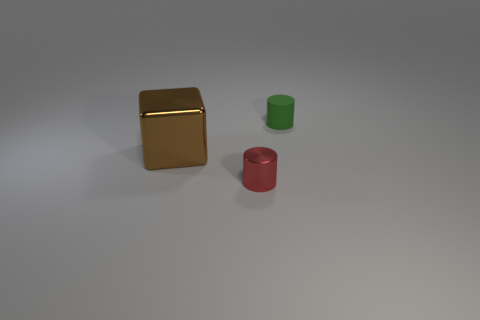Is the number of small red cylinders greater than the number of yellow objects?
Make the answer very short. Yes. Is there any other thing of the same color as the small shiny cylinder?
Keep it short and to the point. No. Do the tiny red cylinder and the small green cylinder have the same material?
Your response must be concise. No. Are there fewer small red metal objects than brown shiny cylinders?
Make the answer very short. No. Is the shape of the brown thing the same as the small green matte thing?
Provide a short and direct response. No. The tiny metal cylinder has what color?
Provide a short and direct response. Red. What number of other things are made of the same material as the big cube?
Your response must be concise. 1. What number of brown objects are small cylinders or large metal cubes?
Provide a short and direct response. 1. Does the small thing that is in front of the tiny green matte object have the same shape as the thing on the right side of the red metallic object?
Offer a very short reply. Yes. There is a big cube; does it have the same color as the thing behind the large brown block?
Your answer should be very brief. No. 